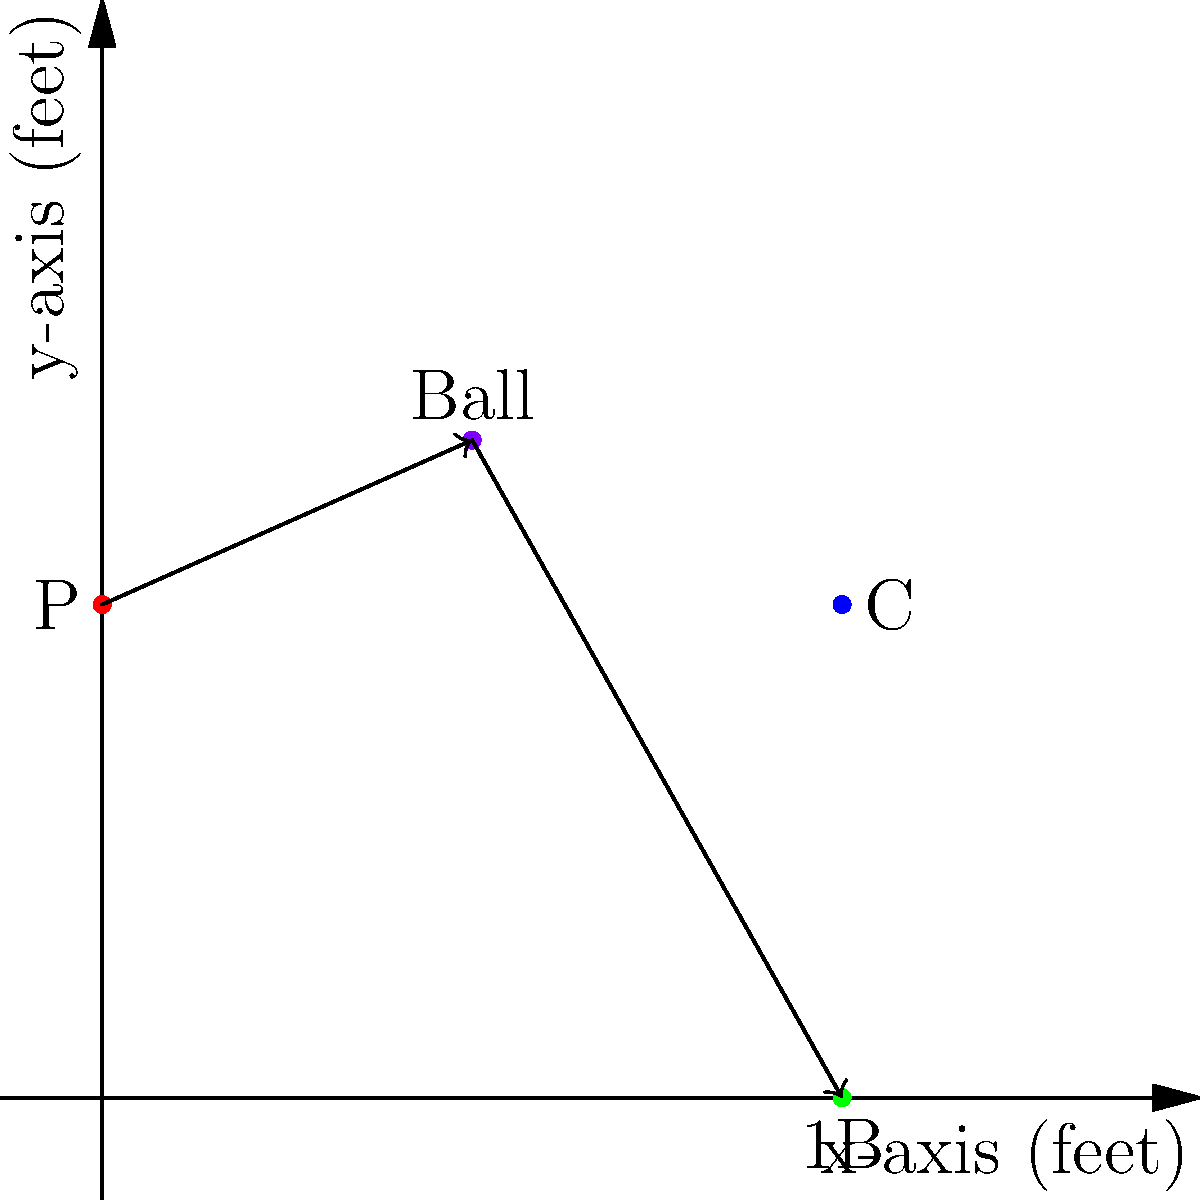In a crucial play during the 9th inning, the pitcher (P) throws a curveball to the catcher (C). The batter hits a ground ball towards first base (1B). Given the coordinates of the players and the ball as shown in the diagram (units in feet), calculate the total distance traveled by the ball from the pitcher to first base, rounded to the nearest foot. To solve this problem, we need to calculate the distance the ball travels in two segments:
1. From the pitcher (P) to the point where the batter hits the ball
2. From the point of contact to first base (1B)

Step 1: Calculate the distance from P to the point of contact
- P coordinates: (0, 60)
- Ball coordinates at point of contact: (45, 80)
- Distance = $\sqrt{(45-0)^2 + (80-60)^2} = \sqrt{2025 + 400} = \sqrt{2425} \approx 49.24$ feet

Step 2: Calculate the distance from the point of contact to 1B
- Ball coordinates at point of contact: (45, 80)
- 1B coordinates: (90, 0)
- Distance = $\sqrt{(90-45)^2 + (0-80)^2} = \sqrt{2025 + 6400} = \sqrt{8425} \approx 91.79$ feet

Step 3: Sum up the total distance
Total distance = 49.24 + 91.79 = 141.03 feet

Step 4: Round to the nearest foot
141.03 rounds to 141 feet
Answer: 141 feet 